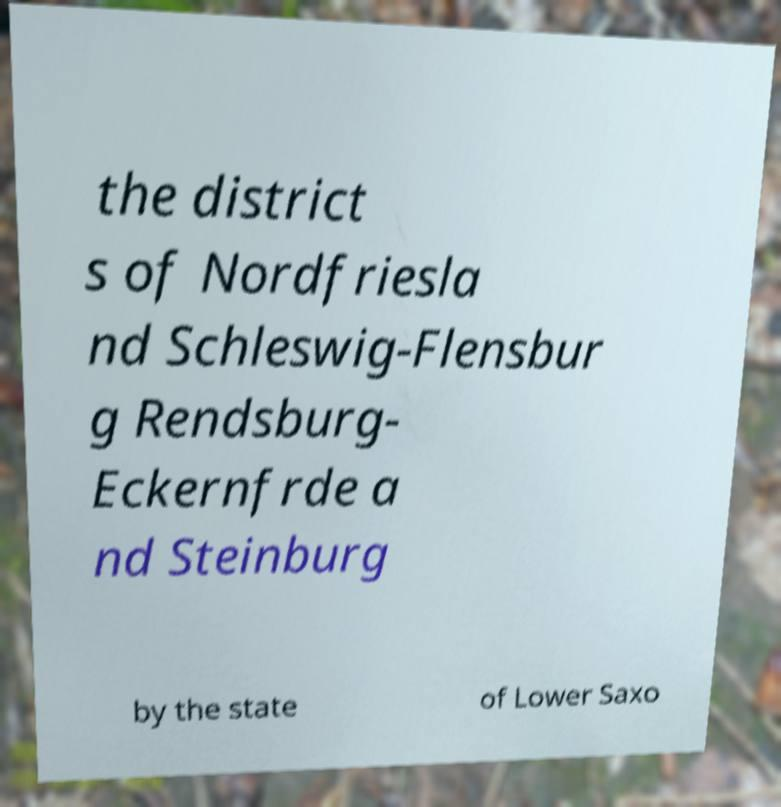Could you assist in decoding the text presented in this image and type it out clearly? the district s of Nordfriesla nd Schleswig-Flensbur g Rendsburg- Eckernfrde a nd Steinburg by the state of Lower Saxo 